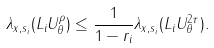Convert formula to latex. <formula><loc_0><loc_0><loc_500><loc_500>\lambda _ { x , s _ { i } } ( L _ { i } U _ { \theta } ^ { \rho } ) \leq \frac { 1 } { 1 - r _ { i } } \lambda _ { x , s _ { i } } ( L _ { i } U _ { \theta } ^ { 2 \tau } ) .</formula> 